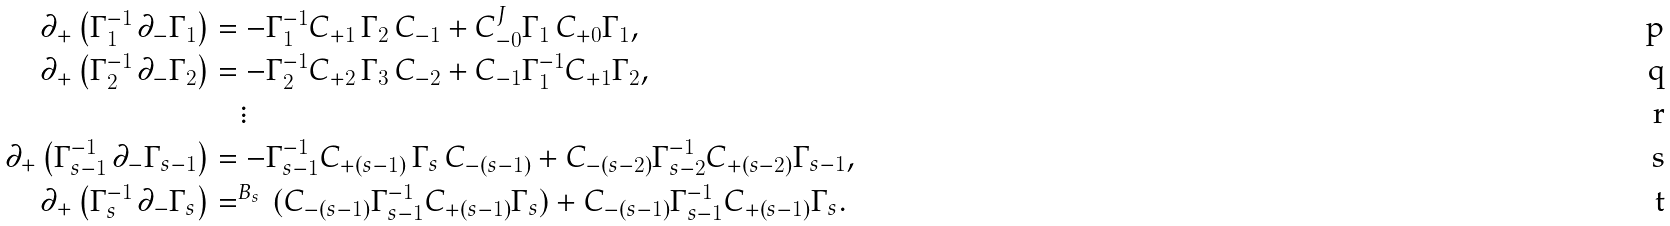<formula> <loc_0><loc_0><loc_500><loc_500>\partial _ { + } \left ( \Gamma _ { 1 } ^ { - 1 } \, \partial _ { - } \Gamma _ { 1 } \right ) & = - \Gamma _ { 1 } ^ { - 1 } C _ { + 1 } \, \Gamma _ { 2 } \, C _ { - 1 } + C _ { - 0 } ^ { J \, } \Gamma _ { 1 } \, C _ { + 0 } \Gamma _ { 1 } , \\ \partial _ { + } \left ( \Gamma _ { 2 } ^ { - 1 } \, \partial _ { - } \Gamma _ { 2 } \right ) & = - \Gamma _ { 2 } ^ { - 1 } C _ { + 2 } \, \Gamma _ { 3 } \, C _ { - 2 } + C _ { - 1 } \Gamma _ { 1 } ^ { - 1 } C _ { + 1 } \Gamma _ { 2 } , \\ & \quad \vdots \\ \partial _ { + } \left ( \Gamma _ { s - 1 } ^ { - 1 } \, \partial _ { - } \Gamma _ { s - 1 } \right ) & = - \Gamma _ { s - 1 } ^ { - 1 } C _ { + ( s - 1 ) } \, \Gamma _ { s } \, C _ { - ( s - 1 ) } + C _ { - ( s - 2 ) } \Gamma _ { s - 2 } ^ { - 1 } C _ { + ( s - 2 ) } \Gamma _ { s - 1 } , \\ \partial _ { + } \left ( \Gamma _ { s } ^ { - 1 } \, \partial _ { - } \Gamma _ { s } \right ) & = ^ { B _ { s } \, } ( C _ { - ( s - 1 ) } \Gamma _ { s - 1 } ^ { - 1 } C _ { + ( s - 1 ) } \Gamma _ { s } ) + C _ { - ( s - 1 ) } \Gamma _ { s - 1 } ^ { - 1 } C _ { + ( s - 1 ) } \Gamma _ { s } .</formula> 